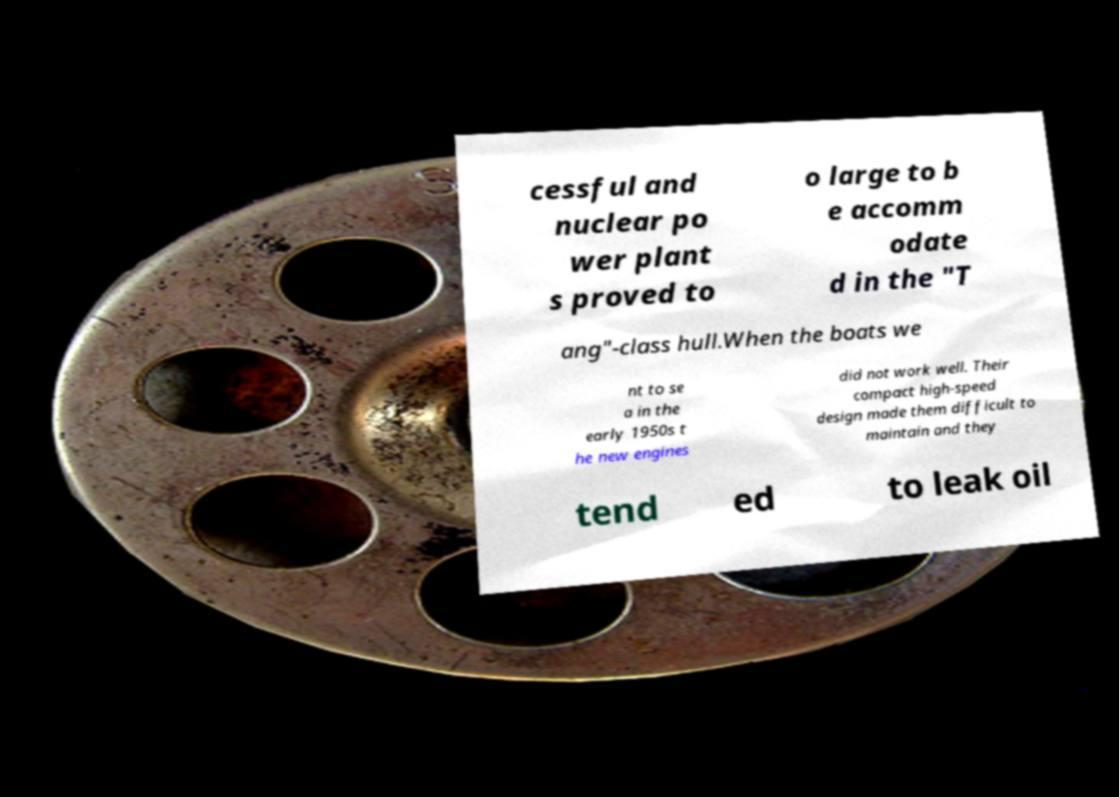There's text embedded in this image that I need extracted. Can you transcribe it verbatim? cessful and nuclear po wer plant s proved to o large to b e accomm odate d in the "T ang"-class hull.When the boats we nt to se a in the early 1950s t he new engines did not work well. Their compact high-speed design made them difficult to maintain and they tend ed to leak oil 